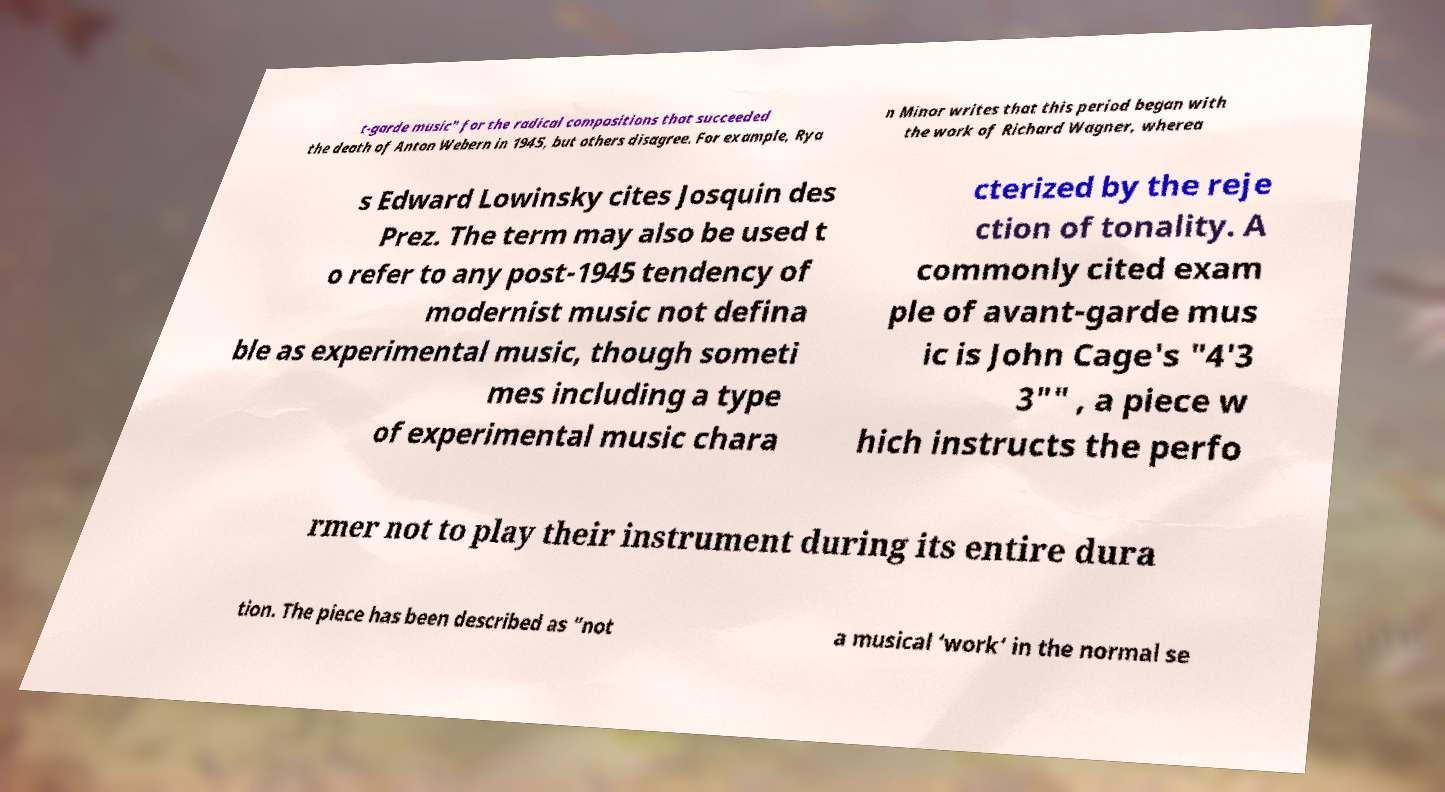For documentation purposes, I need the text within this image transcribed. Could you provide that? t-garde music" for the radical compositions that succeeded the death of Anton Webern in 1945, but others disagree. For example, Rya n Minor writes that this period began with the work of Richard Wagner, wherea s Edward Lowinsky cites Josquin des Prez. The term may also be used t o refer to any post-1945 tendency of modernist music not defina ble as experimental music, though someti mes including a type of experimental music chara cterized by the reje ction of tonality. A commonly cited exam ple of avant-garde mus ic is John Cage's "4'3 3"" , a piece w hich instructs the perfo rmer not to play their instrument during its entire dura tion. The piece has been described as “not a musical ‘work’ in the normal se 